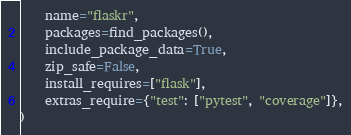<code> <loc_0><loc_0><loc_500><loc_500><_Python_>    name="flaskr",
    packages=find_packages(),
    include_package_data=True,
    zip_safe=False,
    install_requires=["flask"],
    extras_require={"test": ["pytest", "coverage"]},
)
</code> 